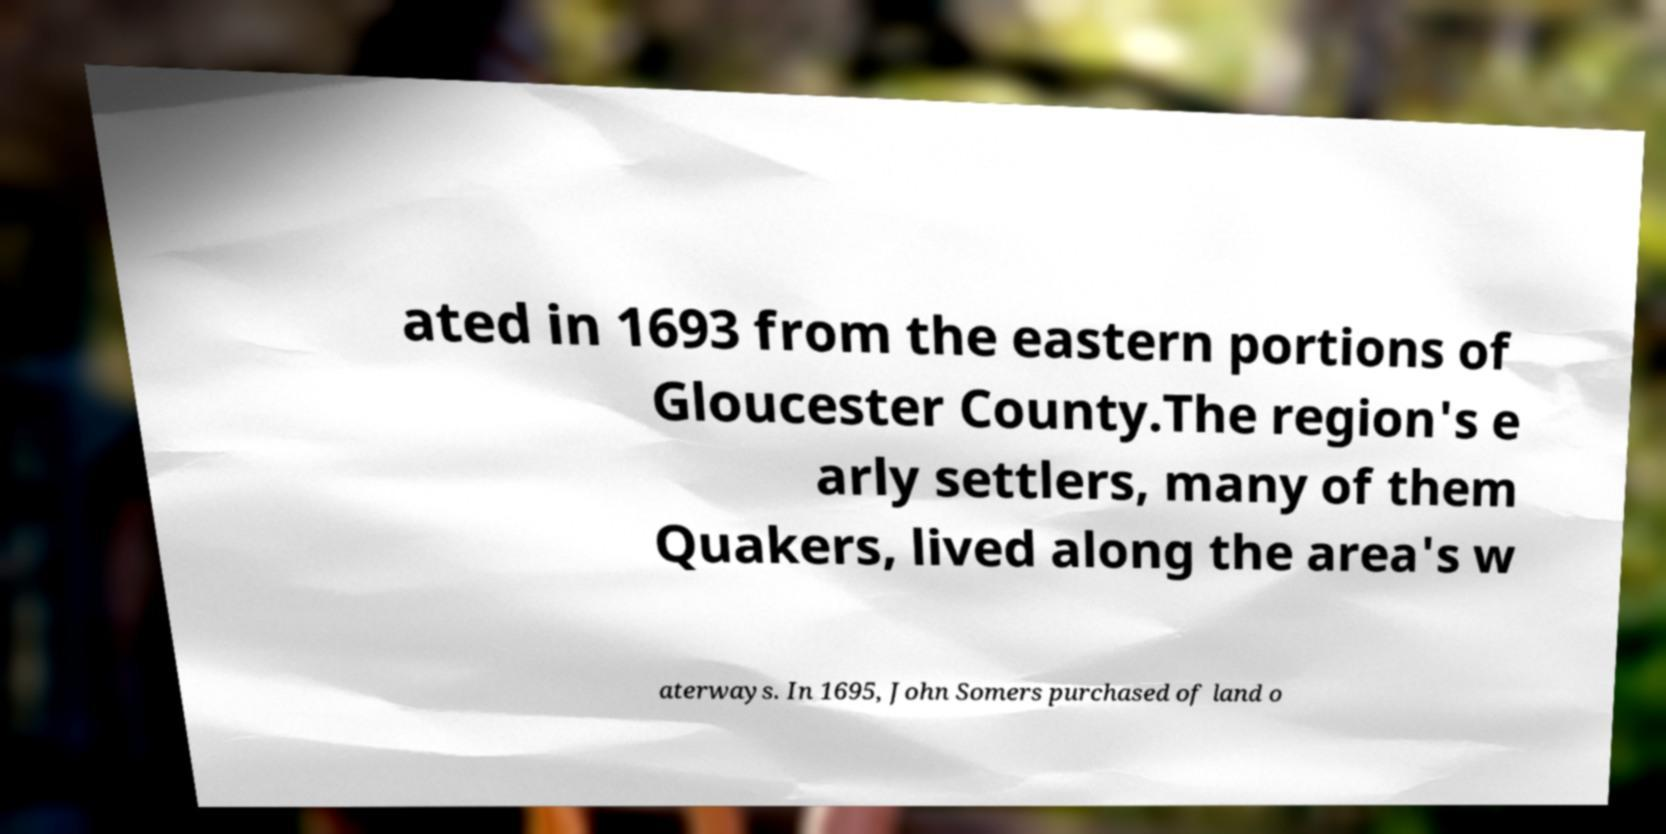Can you accurately transcribe the text from the provided image for me? ated in 1693 from the eastern portions of Gloucester County.The region's e arly settlers, many of them Quakers, lived along the area's w aterways. In 1695, John Somers purchased of land o 